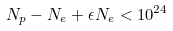Convert formula to latex. <formula><loc_0><loc_0><loc_500><loc_500>N _ { p } - N _ { e } + \epsilon N _ { e } < 1 0 ^ { 2 4 }</formula> 